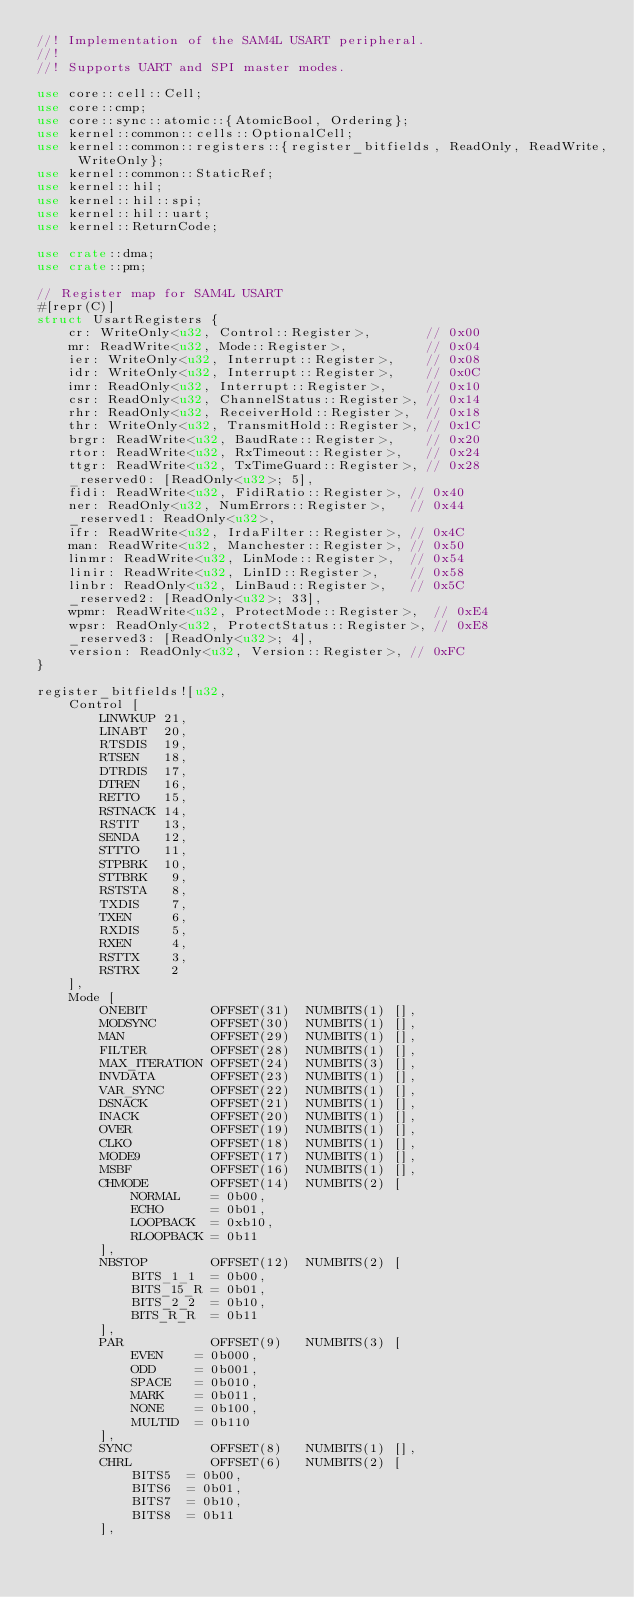<code> <loc_0><loc_0><loc_500><loc_500><_Rust_>//! Implementation of the SAM4L USART peripheral.
//!
//! Supports UART and SPI master modes.

use core::cell::Cell;
use core::cmp;
use core::sync::atomic::{AtomicBool, Ordering};
use kernel::common::cells::OptionalCell;
use kernel::common::registers::{register_bitfields, ReadOnly, ReadWrite, WriteOnly};
use kernel::common::StaticRef;
use kernel::hil;
use kernel::hil::spi;
use kernel::hil::uart;
use kernel::ReturnCode;

use crate::dma;
use crate::pm;

// Register map for SAM4L USART
#[repr(C)]
struct UsartRegisters {
    cr: WriteOnly<u32, Control::Register>,       // 0x00
    mr: ReadWrite<u32, Mode::Register>,          // 0x04
    ier: WriteOnly<u32, Interrupt::Register>,    // 0x08
    idr: WriteOnly<u32, Interrupt::Register>,    // 0x0C
    imr: ReadOnly<u32, Interrupt::Register>,     // 0x10
    csr: ReadOnly<u32, ChannelStatus::Register>, // 0x14
    rhr: ReadOnly<u32, ReceiverHold::Register>,  // 0x18
    thr: WriteOnly<u32, TransmitHold::Register>, // 0x1C
    brgr: ReadWrite<u32, BaudRate::Register>,    // 0x20
    rtor: ReadWrite<u32, RxTimeout::Register>,   // 0x24
    ttgr: ReadWrite<u32, TxTimeGuard::Register>, // 0x28
    _reserved0: [ReadOnly<u32>; 5],
    fidi: ReadWrite<u32, FidiRatio::Register>, // 0x40
    ner: ReadOnly<u32, NumErrors::Register>,   // 0x44
    _reserved1: ReadOnly<u32>,
    ifr: ReadWrite<u32, IrdaFilter::Register>, // 0x4C
    man: ReadWrite<u32, Manchester::Register>, // 0x50
    linmr: ReadWrite<u32, LinMode::Register>,  // 0x54
    linir: ReadWrite<u32, LinID::Register>,    // 0x58
    linbr: ReadOnly<u32, LinBaud::Register>,   // 0x5C
    _reserved2: [ReadOnly<u32>; 33],
    wpmr: ReadWrite<u32, ProtectMode::Register>,  // 0xE4
    wpsr: ReadOnly<u32, ProtectStatus::Register>, // 0xE8
    _reserved3: [ReadOnly<u32>; 4],
    version: ReadOnly<u32, Version::Register>, // 0xFC
}

register_bitfields![u32,
    Control [
        LINWKUP 21,
        LINABT  20,
        RTSDIS  19,
        RTSEN   18,
        DTRDIS  17,
        DTREN   16,
        RETTO   15,
        RSTNACK 14,
        RSTIT   13,
        SENDA   12,
        STTTO   11,
        STPBRK  10,
        STTBRK   9,
        RSTSTA   8,
        TXDIS    7,
        TXEN     6,
        RXDIS    5,
        RXEN     4,
        RSTTX    3,
        RSTRX    2
    ],
    Mode [
        ONEBIT        OFFSET(31)  NUMBITS(1) [],
        MODSYNC       OFFSET(30)  NUMBITS(1) [],
        MAN           OFFSET(29)  NUMBITS(1) [],
        FILTER        OFFSET(28)  NUMBITS(1) [],
        MAX_ITERATION OFFSET(24)  NUMBITS(3) [],
        INVDATA       OFFSET(23)  NUMBITS(1) [],
        VAR_SYNC      OFFSET(22)  NUMBITS(1) [],
        DSNACK        OFFSET(21)  NUMBITS(1) [],
        INACK         OFFSET(20)  NUMBITS(1) [],
        OVER          OFFSET(19)  NUMBITS(1) [],
        CLKO          OFFSET(18)  NUMBITS(1) [],
        MODE9         OFFSET(17)  NUMBITS(1) [],
        MSBF          OFFSET(16)  NUMBITS(1) [],
        CHMODE        OFFSET(14)  NUMBITS(2) [
            NORMAL    = 0b00,
            ECHO      = 0b01,
            LOOPBACK  = 0xb10,
            RLOOPBACK = 0b11
        ],
        NBSTOP        OFFSET(12)  NUMBITS(2) [
            BITS_1_1  = 0b00,
            BITS_15_R = 0b01,
            BITS_2_2  = 0b10,
            BITS_R_R  = 0b11
        ],
        PAR           OFFSET(9)   NUMBITS(3) [
            EVEN    = 0b000,
            ODD     = 0b001,
            SPACE   = 0b010,
            MARK    = 0b011,
            NONE    = 0b100,
            MULTID  = 0b110
        ],
        SYNC          OFFSET(8)   NUMBITS(1) [],
        CHRL          OFFSET(6)   NUMBITS(2) [
            BITS5  = 0b00,
            BITS6  = 0b01,
            BITS7  = 0b10,
            BITS8  = 0b11
        ],</code> 